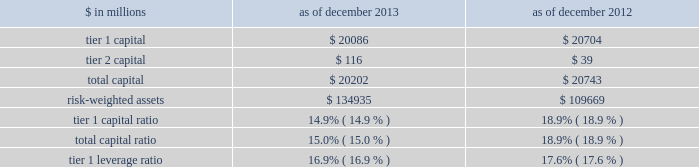Notes to consolidated financial statements under the regulatory framework for prompt corrective action applicable to gs bank usa , in order to meet the quantitative requirements for being a 201cwell-capitalized 201d depository institution , gs bank usa is required to maintain a tier 1 capital ratio of at least 6% ( 6 % ) , a total capital ratio of at least 10% ( 10 % ) and a tier 1 leverage ratio of at least 5% ( 5 % ) .
Gs bank usa agreed with the federal reserve board to maintain minimum capital ratios in excess of these 201cwell- capitalized 201d levels .
Accordingly , for a period of time , gs bank usa is expected to maintain a tier 1 capital ratio of at least 8% ( 8 % ) , a total capital ratio of at least 11% ( 11 % ) and a tier 1 leverage ratio of at least 6% ( 6 % ) .
As noted in the table below , gs bank usa was in compliance with these minimum capital requirements as of december 2013 and december 2012 .
The table below presents information regarding gs bank usa 2019s regulatory capital ratios under basel i , as implemented by the federal reserve board .
The information as of december 2013 reflects the revised market risk regulatory capital requirements , which became effective on january 1 , 2013 .
These changes resulted in increased regulatory capital requirements for market risk .
The information as of december 2012 is prior to the implementation of these revised market risk regulatory capital requirements. .
The revised capital framework described above is also applicable to gs bank usa , which is an advanced approach banking organization under this framework .
Gs bank usa has also been informed by the federal reserve board that it has completed a satisfactory parallel run , as required of advanced approach banking organizations under the revised capital framework , and therefore changes to its calculations of rwas will take effect beginning with the second quarter of 2014 .
Under the revised capital framework , as of january 1 , 2014 , gs bank usa became subject to a new minimum cet1 ratio requirement of 4% ( 4 % ) , increasing to 4.5% ( 4.5 % ) in 2015 .
In addition , the revised capital framework changes the standards for 201cwell-capitalized 201d status under prompt corrective action regulations beginning january 1 , 2015 by , among other things , introducing a cet1 ratio requirement of 6.5% ( 6.5 % ) and increasing the tier 1 capital ratio requirement from 6% ( 6 % ) to 8% ( 8 % ) .
In addition , commencing january 1 , 2018 , advanced approach banking organizations must have a supplementary leverage ratio of 3% ( 3 % ) or greater .
The basel committee published its final guidelines for calculating incremental capital requirements for domestic systemically important banking institutions ( d-sibs ) .
These guidelines are complementary to the framework outlined above for g-sibs .
The impact of these guidelines on the regulatory capital requirements of gs bank usa will depend on how they are implemented by the banking regulators in the united states .
The deposits of gs bank usa are insured by the fdic to the extent provided by law .
The federal reserve board requires depository institutions to maintain cash reserves with a federal reserve bank .
The amount deposited by the firm 2019s depository institution held at the federal reserve bank was approximately $ 50.39 billion and $ 58.67 billion as of december 2013 and december 2012 , respectively , which exceeded required reserve amounts by $ 50.29 billion and $ 58.59 billion as of december 2013 and december 2012 , respectively .
Transactions between gs bank usa and its subsidiaries and group inc .
And its subsidiaries and affiliates ( other than , generally , subsidiaries of gs bank usa ) are regulated by the federal reserve board .
These regulations generally limit the types and amounts of transactions ( including credit extensions from gs bank usa ) that may take place and generally require those transactions to be on market terms or better to gs bank usa .
The firm 2019s principal non-u.s .
Bank subsidiary , gsib , is a wholly-owned credit institution , regulated by the prudential regulation authority ( pra ) and the financial conduct authority ( fca ) and is subject to minimum capital requirements .
As of december 2013 and december 2012 , gsib was in compliance with all regulatory capital requirements .
Goldman sachs 2013 annual report 193 .
What was the change in millions in tier 1 capital between 2012 and 2013? 
Computations: (20086 - 20704)
Answer: -618.0. 